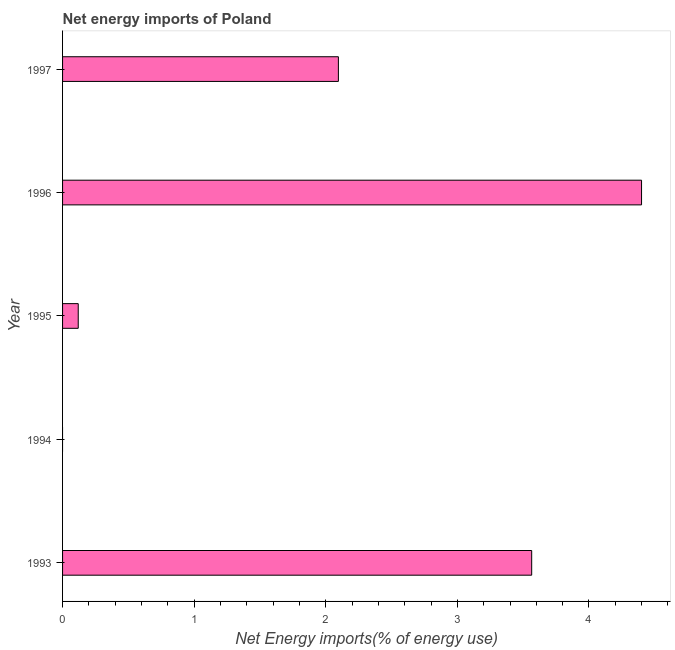Does the graph contain any zero values?
Your answer should be very brief. Yes. What is the title of the graph?
Offer a terse response. Net energy imports of Poland. What is the label or title of the X-axis?
Offer a very short reply. Net Energy imports(% of energy use). What is the label or title of the Y-axis?
Offer a very short reply. Year. What is the energy imports in 1997?
Make the answer very short. 2.1. Across all years, what is the maximum energy imports?
Offer a very short reply. 4.4. Across all years, what is the minimum energy imports?
Your answer should be very brief. 0. What is the sum of the energy imports?
Provide a short and direct response. 10.18. What is the difference between the energy imports in 1996 and 1997?
Your answer should be very brief. 2.3. What is the average energy imports per year?
Your answer should be compact. 2.04. What is the median energy imports?
Offer a terse response. 2.1. In how many years, is the energy imports greater than 3.6 %?
Provide a succinct answer. 1. What is the ratio of the energy imports in 1993 to that in 1995?
Provide a short and direct response. 29.94. Is the difference between the energy imports in 1995 and 1996 greater than the difference between any two years?
Your response must be concise. No. What is the difference between the highest and the second highest energy imports?
Make the answer very short. 0.83. Is the sum of the energy imports in 1995 and 1997 greater than the maximum energy imports across all years?
Your answer should be very brief. No. What is the difference between the highest and the lowest energy imports?
Your answer should be very brief. 4.4. How many bars are there?
Keep it short and to the point. 4. Are all the bars in the graph horizontal?
Offer a terse response. Yes. How many years are there in the graph?
Offer a very short reply. 5. What is the difference between two consecutive major ticks on the X-axis?
Your answer should be very brief. 1. Are the values on the major ticks of X-axis written in scientific E-notation?
Ensure brevity in your answer.  No. What is the Net Energy imports(% of energy use) in 1993?
Your response must be concise. 3.56. What is the Net Energy imports(% of energy use) in 1995?
Make the answer very short. 0.12. What is the Net Energy imports(% of energy use) of 1996?
Provide a succinct answer. 4.4. What is the Net Energy imports(% of energy use) of 1997?
Offer a very short reply. 2.1. What is the difference between the Net Energy imports(% of energy use) in 1993 and 1995?
Provide a succinct answer. 3.45. What is the difference between the Net Energy imports(% of energy use) in 1993 and 1996?
Your response must be concise. -0.83. What is the difference between the Net Energy imports(% of energy use) in 1993 and 1997?
Ensure brevity in your answer.  1.47. What is the difference between the Net Energy imports(% of energy use) in 1995 and 1996?
Your response must be concise. -4.28. What is the difference between the Net Energy imports(% of energy use) in 1995 and 1997?
Your response must be concise. -1.98. What is the difference between the Net Energy imports(% of energy use) in 1996 and 1997?
Your response must be concise. 2.3. What is the ratio of the Net Energy imports(% of energy use) in 1993 to that in 1995?
Make the answer very short. 29.94. What is the ratio of the Net Energy imports(% of energy use) in 1993 to that in 1996?
Ensure brevity in your answer.  0.81. What is the ratio of the Net Energy imports(% of energy use) in 1993 to that in 1997?
Provide a succinct answer. 1.7. What is the ratio of the Net Energy imports(% of energy use) in 1995 to that in 1996?
Give a very brief answer. 0.03. What is the ratio of the Net Energy imports(% of energy use) in 1995 to that in 1997?
Provide a succinct answer. 0.06. What is the ratio of the Net Energy imports(% of energy use) in 1996 to that in 1997?
Keep it short and to the point. 2.1. 